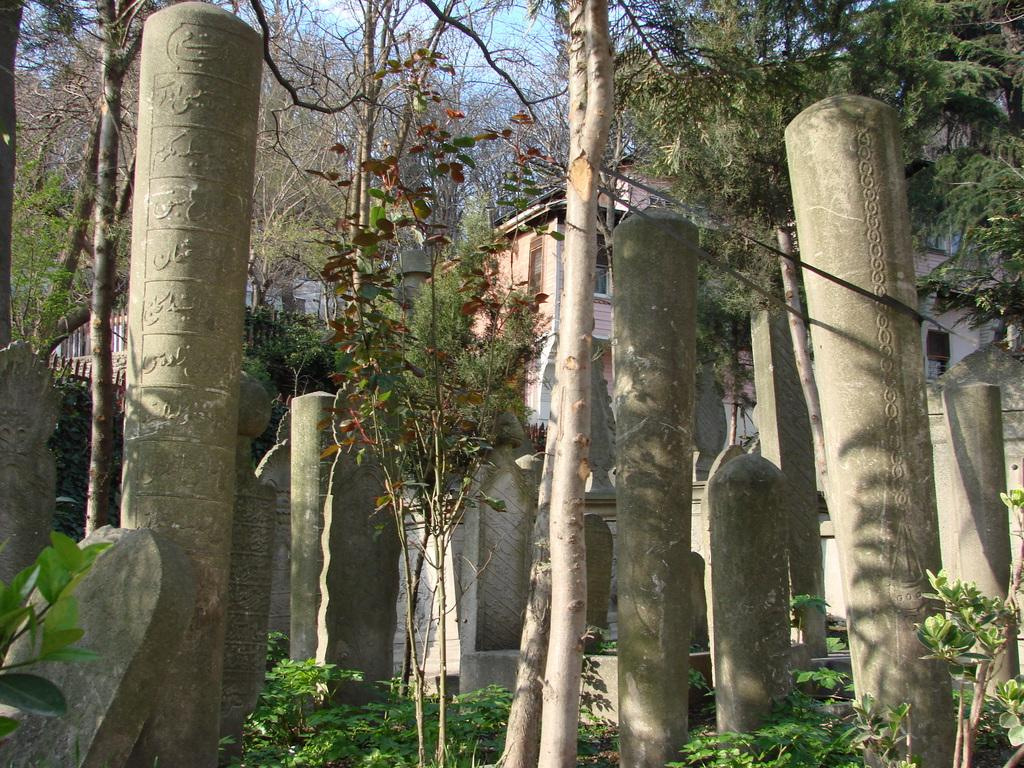What type of vegetation can be seen in the image? There are trees in the image. What structures are present in the image? There are poles and a building in the image. What else can be seen in the image besides the trees and structures? There are some objects in the image. What is visible in the background of the image? The sky is visible in the background of the image. Can you tell me how many locks are on the building in the image? There is no information about locks on the building in the image, so it cannot be determined. What type of recess is visible in the image? There is no recess present in the image. 